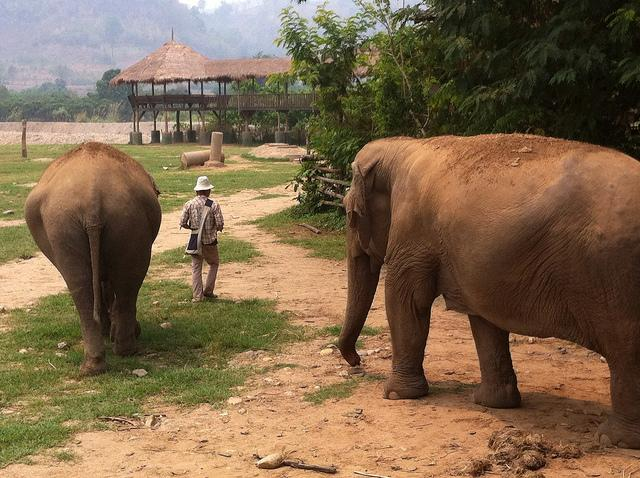How many elephants are following after the man wearing a white hat? two 